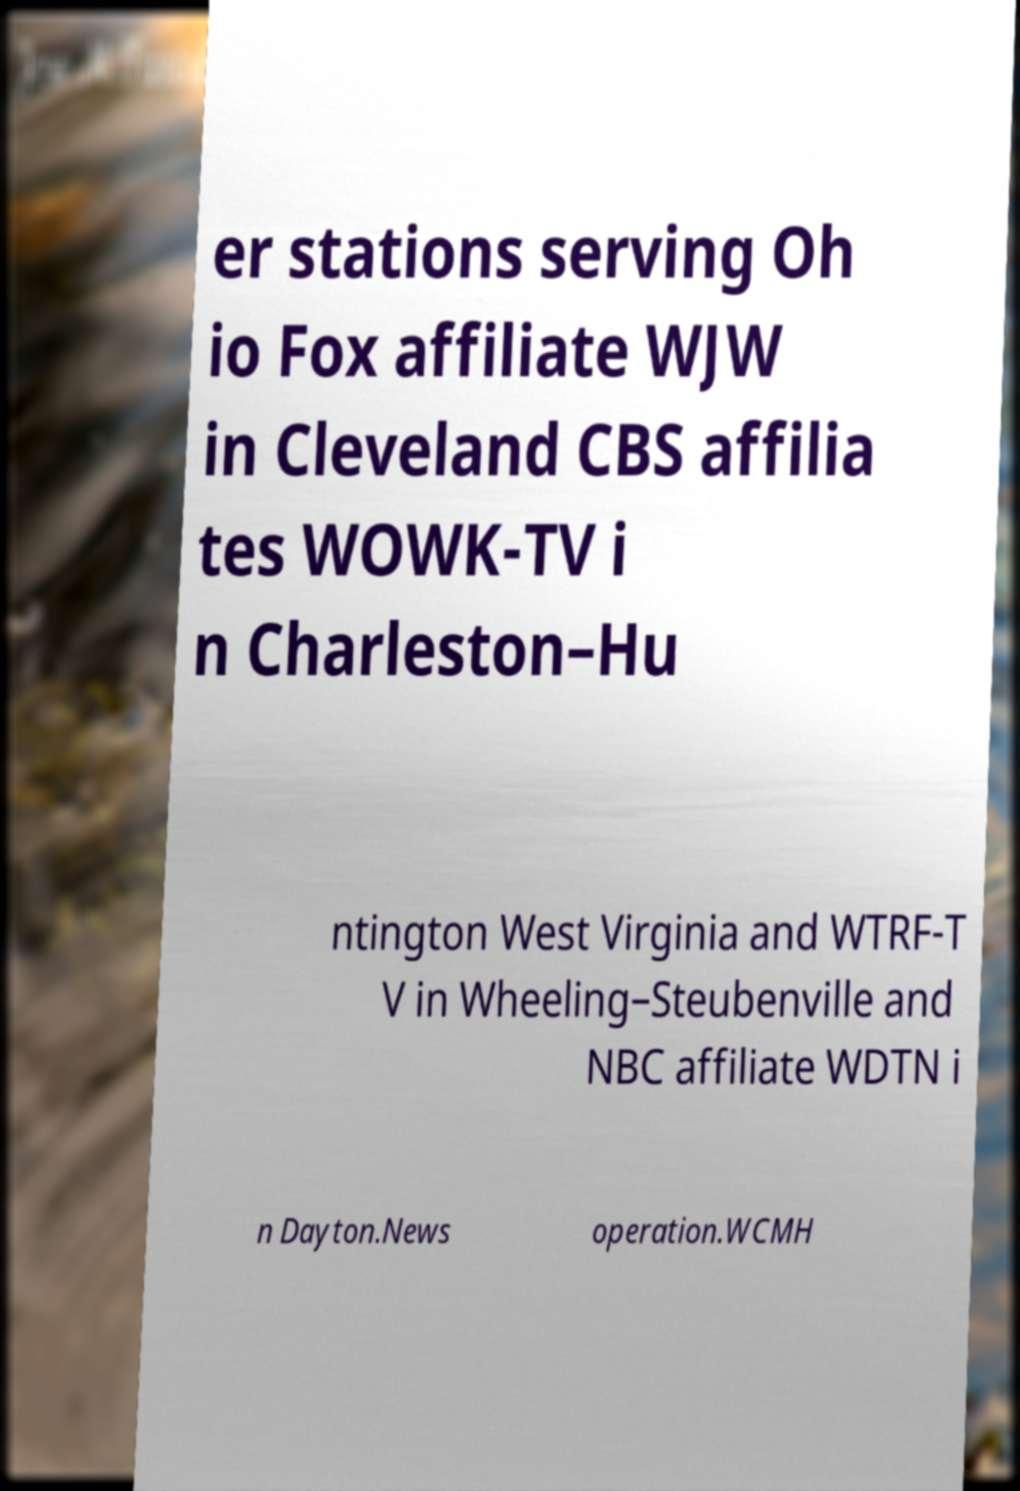Please identify and transcribe the text found in this image. er stations serving Oh io Fox affiliate WJW in Cleveland CBS affilia tes WOWK-TV i n Charleston–Hu ntington West Virginia and WTRF-T V in Wheeling–Steubenville and NBC affiliate WDTN i n Dayton.News operation.WCMH 